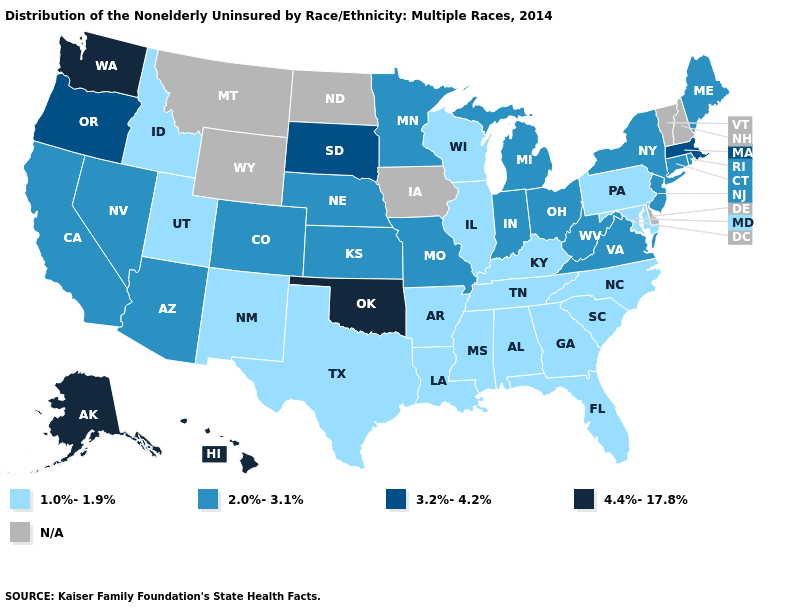Does Arizona have the highest value in the USA?
Write a very short answer. No. Which states have the lowest value in the USA?
Write a very short answer. Alabama, Arkansas, Florida, Georgia, Idaho, Illinois, Kentucky, Louisiana, Maryland, Mississippi, New Mexico, North Carolina, Pennsylvania, South Carolina, Tennessee, Texas, Utah, Wisconsin. What is the value of Connecticut?
Be succinct. 2.0%-3.1%. Name the states that have a value in the range 3.2%-4.2%?
Give a very brief answer. Massachusetts, Oregon, South Dakota. Name the states that have a value in the range 3.2%-4.2%?
Write a very short answer. Massachusetts, Oregon, South Dakota. What is the highest value in states that border New York?
Write a very short answer. 3.2%-4.2%. What is the value of Mississippi?
Short answer required. 1.0%-1.9%. Does South Dakota have the highest value in the MidWest?
Short answer required. Yes. Which states have the lowest value in the West?
Keep it brief. Idaho, New Mexico, Utah. Name the states that have a value in the range 4.4%-17.8%?
Give a very brief answer. Alaska, Hawaii, Oklahoma, Washington. Among the states that border Wyoming , which have the lowest value?
Keep it brief. Idaho, Utah. What is the value of Pennsylvania?
Short answer required. 1.0%-1.9%. Name the states that have a value in the range 3.2%-4.2%?
Keep it brief. Massachusetts, Oregon, South Dakota. Name the states that have a value in the range 3.2%-4.2%?
Give a very brief answer. Massachusetts, Oregon, South Dakota. 